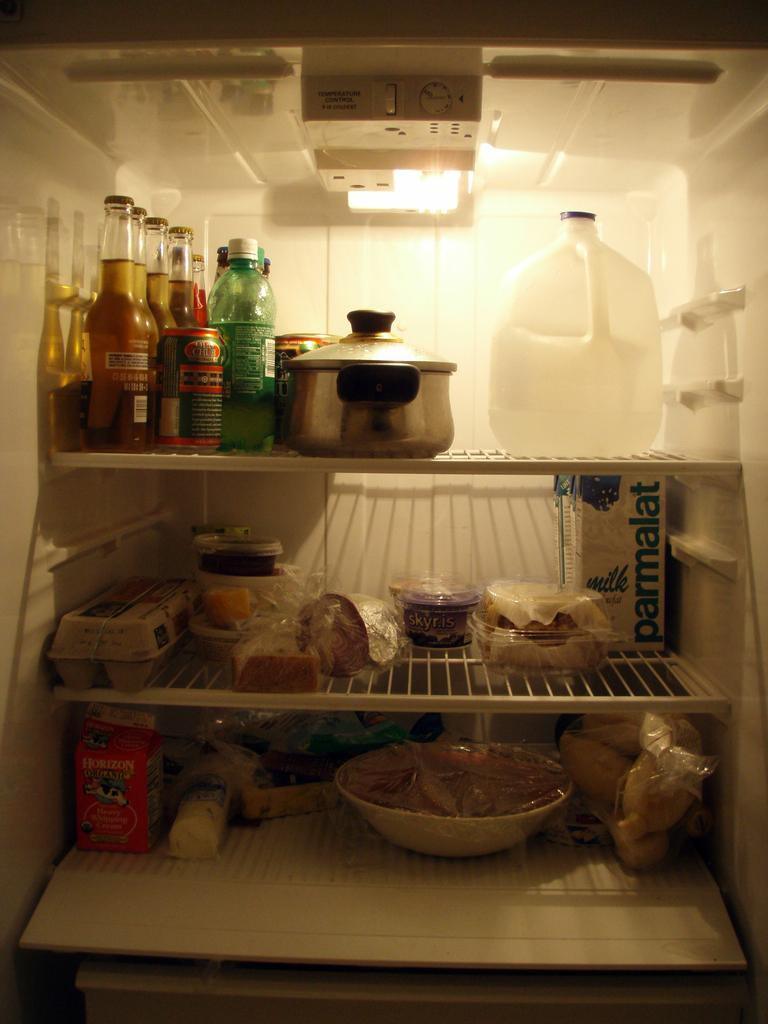Provide a one-sentence caption for the provided image. A refridgerator that includes Horizon milk and milk called parmalat. 